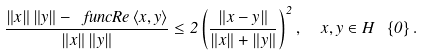<formula> <loc_0><loc_0><loc_500><loc_500>\frac { \left \| x \right \| \left \| y \right \| - \ f u n c { R e } \left \langle x , y \right \rangle } { \left \| x \right \| \left \| y \right \| } \leq 2 \left ( \frac { \left \| x - y \right \| } { \left \| x \right \| + \left \| y \right \| } \right ) ^ { 2 } , \ \ x , y \in H \ \left \{ 0 \right \} .</formula> 